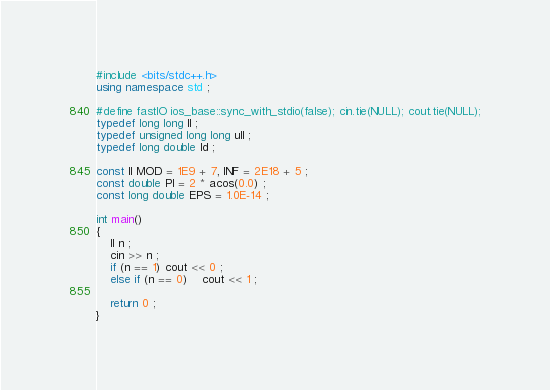<code> <loc_0><loc_0><loc_500><loc_500><_C++_>#include <bits/stdc++.h>
using namespace std ;

#define fastIO ios_base::sync_with_stdio(false); cin.tie(NULL); cout.tie(NULL);
typedef long long ll ;
typedef unsigned long long ull ;
typedef long double ld ;

const ll MOD = 1E9 + 7, INF = 2E18 + 5 ;
const double PI = 2 * acos(0.0) ;
const long double EPS = 1.0E-14 ;

int main()
{
    ll n ;
    cin >> n ;
    if (n == 1) cout << 0 ;
    else if (n == 0)    cout << 1 ;

    return 0 ;
}
</code> 